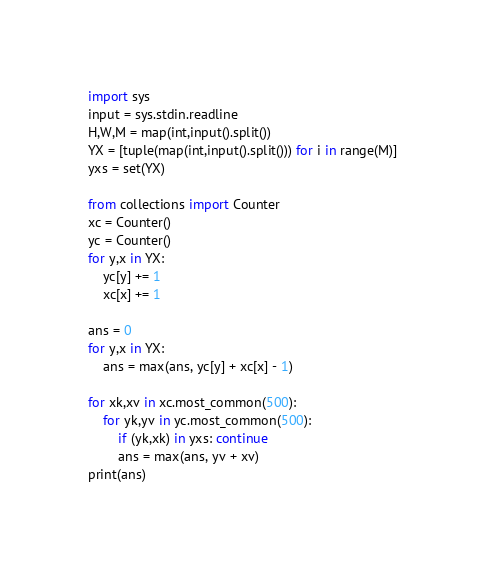Convert code to text. <code><loc_0><loc_0><loc_500><loc_500><_Python_>import sys
input = sys.stdin.readline
H,W,M = map(int,input().split())
YX = [tuple(map(int,input().split())) for i in range(M)]
yxs = set(YX)

from collections import Counter
xc = Counter()
yc = Counter()
for y,x in YX:
    yc[y] += 1
    xc[x] += 1

ans = 0
for y,x in YX:
    ans = max(ans, yc[y] + xc[x] - 1)

for xk,xv in xc.most_common(500):
    for yk,yv in yc.most_common(500):
        if (yk,xk) in yxs: continue
        ans = max(ans, yv + xv)
print(ans)</code> 